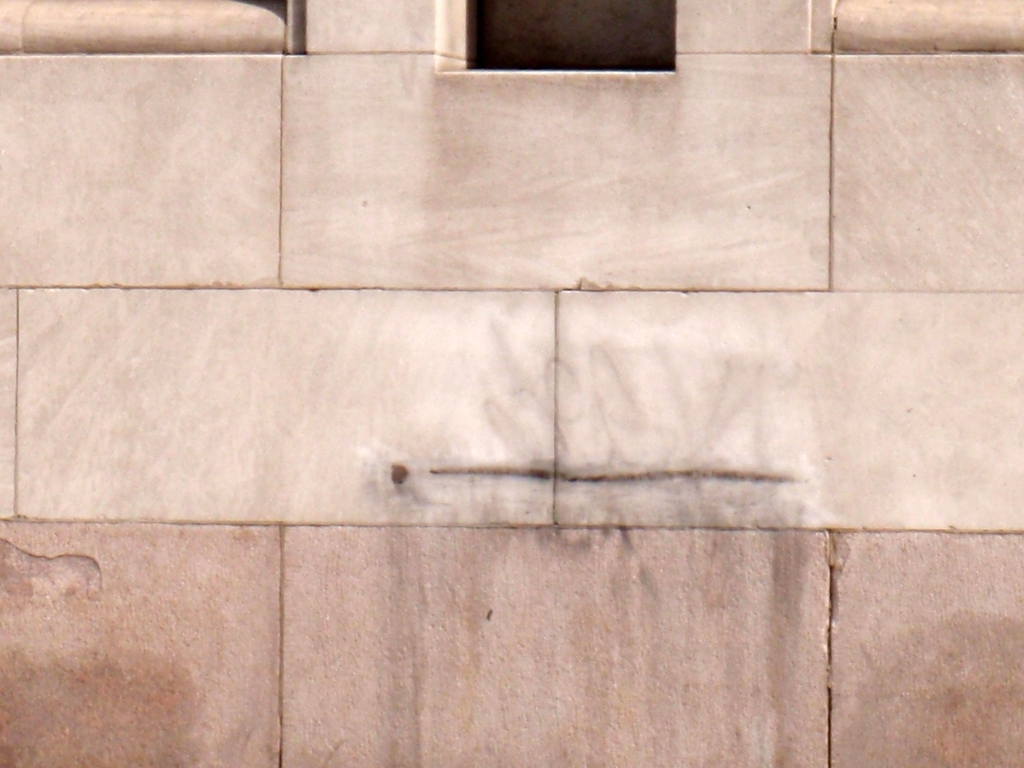Is there anything that indicates the location or setting of this wall? While there are no explicit markers in the visible portion of the image to definitively identify the location, features such as the stonework and discoloration patterns might imply an urban environment, potentially subjected to significant environmental exposure.  Could the faint graffiti contribute to historical or cultural context? Graffiti can sometimes provide insights into the cultural or social environment of an area. Although this particular example is indistinct, if it were decipherable, it might suggest local trends, conflicts, or social messages prevalent in the community during the time it was created. 